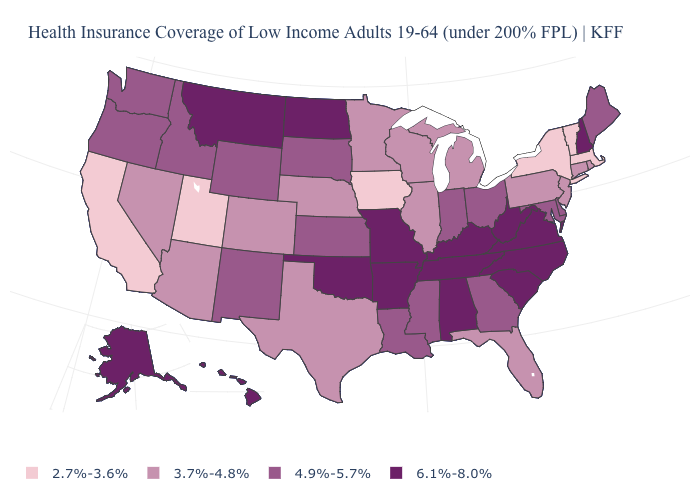Does Tennessee have the highest value in the USA?
Give a very brief answer. Yes. What is the value of West Virginia?
Keep it brief. 6.1%-8.0%. Name the states that have a value in the range 2.7%-3.6%?
Be succinct. California, Iowa, Massachusetts, New York, Utah, Vermont. Among the states that border Vermont , which have the lowest value?
Quick response, please. Massachusetts, New York. Among the states that border West Virginia , which have the highest value?
Give a very brief answer. Kentucky, Virginia. What is the highest value in the USA?
Concise answer only. 6.1%-8.0%. Among the states that border Texas , which have the lowest value?
Be succinct. Louisiana, New Mexico. Among the states that border Missouri , which have the highest value?
Short answer required. Arkansas, Kentucky, Oklahoma, Tennessee. Does Iowa have the lowest value in the USA?
Keep it brief. Yes. What is the lowest value in states that border Maryland?
Write a very short answer. 3.7%-4.8%. What is the value of Ohio?
Short answer required. 4.9%-5.7%. Does Maryland have the lowest value in the USA?
Quick response, please. No. Among the states that border Alabama , does Florida have the lowest value?
Be succinct. Yes. How many symbols are there in the legend?
Quick response, please. 4. 